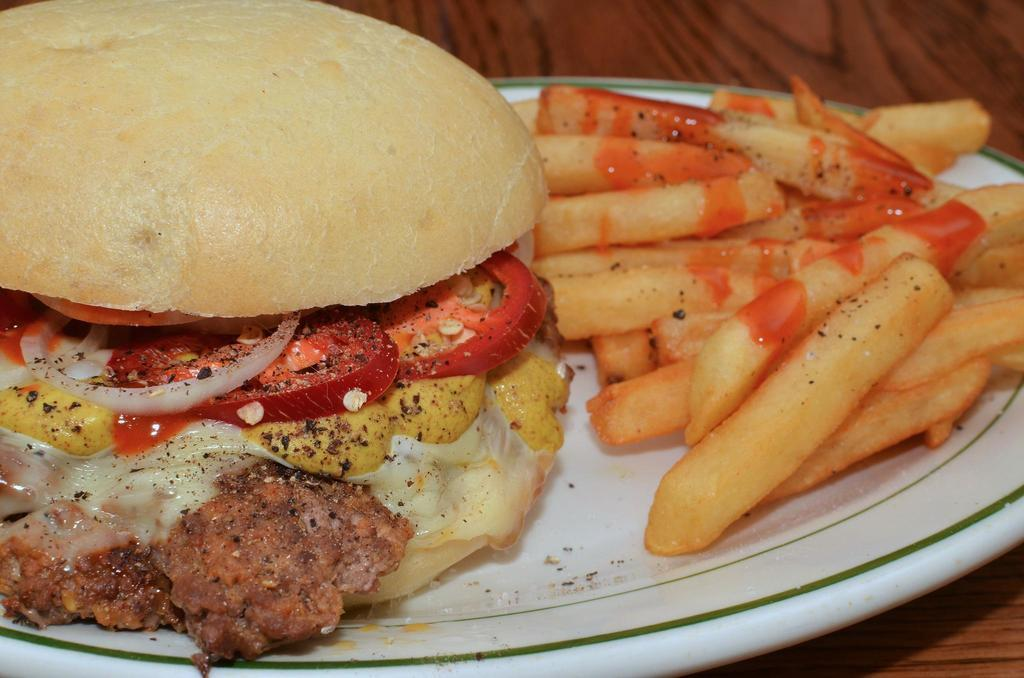What type of food is shown in the image? There is a burger in the image. What else is on the plate with the burger? There are fries in the image. Where is the plate with the burger and fries located? The plate is on a table. What type of badge is visible on the burger in the image? There is no badge present on the burger in the image. What color is the silverware used to eat the burger and fries in the image? There is no silverware visible in the image. 